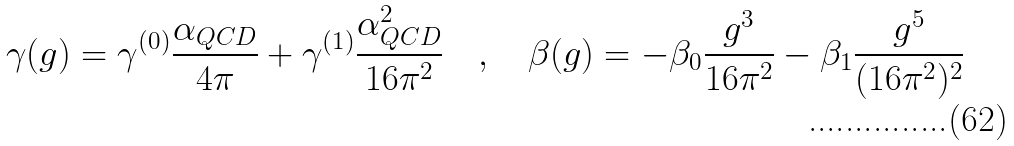Convert formula to latex. <formula><loc_0><loc_0><loc_500><loc_500>\gamma ( g ) = \gamma ^ { ( 0 ) } \frac { \alpha _ { Q C D } } { 4 \pi } + \gamma ^ { ( 1 ) } \frac { \alpha _ { Q C D } ^ { 2 } } { 1 6 \pi ^ { 2 } } \quad , \quad \beta ( g ) = - \beta _ { 0 } \frac { g ^ { 3 } } { 1 6 \pi ^ { 2 } } - \beta _ { 1 } \frac { g ^ { 5 } } { ( 1 6 \pi ^ { 2 } ) ^ { 2 } }</formula> 